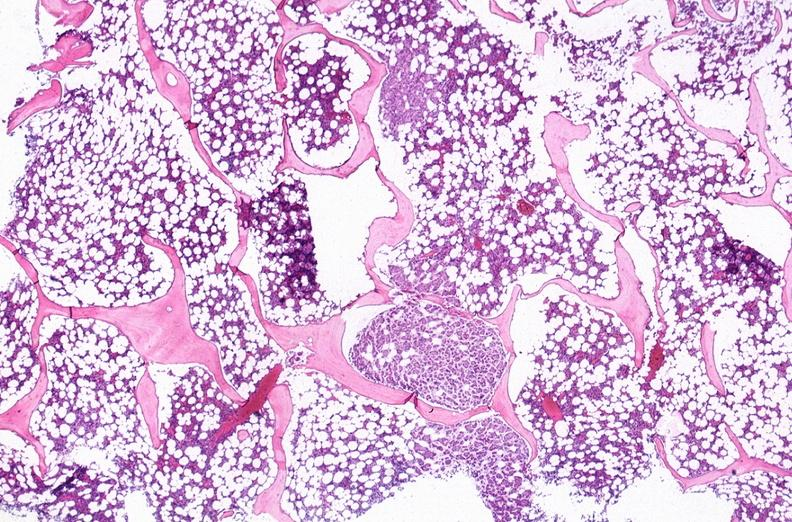what does this image show?
Answer the question using a single word or phrase. Breast cancer metastasis to bone marrow 